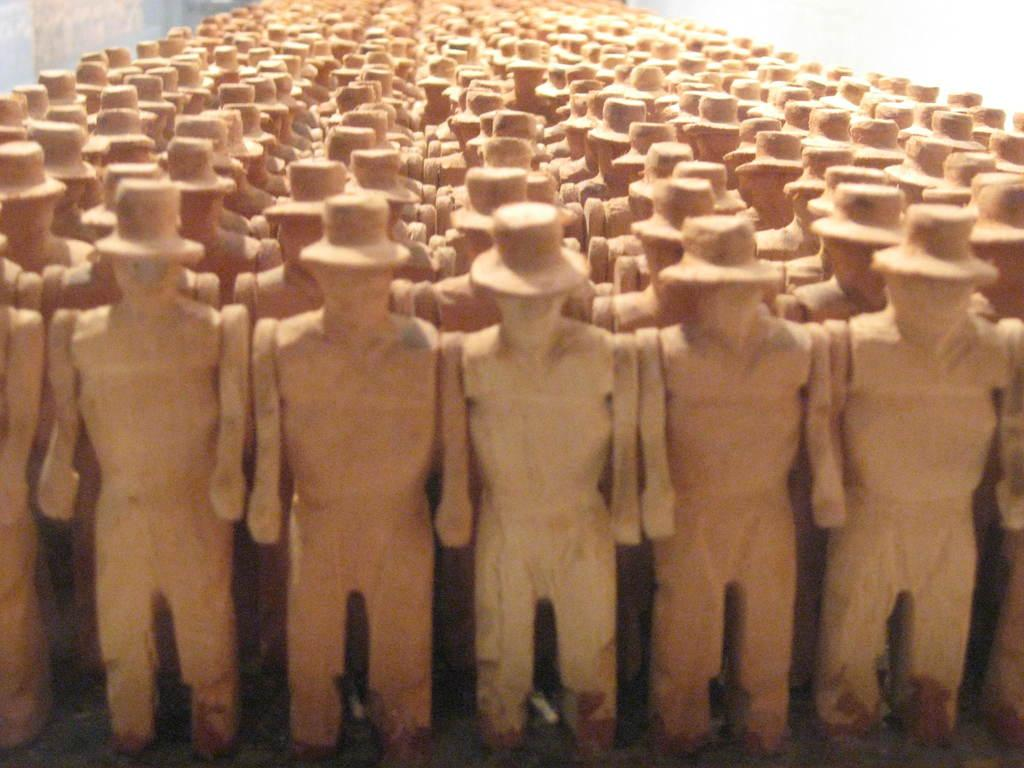What is the main subject of the image? The main subject of the image is many statues. Can you describe the statues in the image? The statues are of a person standing. What is the person depicted in the statues wearing? The person depicted in the statues is wearing a hat. Where can the honey be found in the image? There is no honey present in the image. How many chickens are visible in the image? There are no chickens visible in the image. 